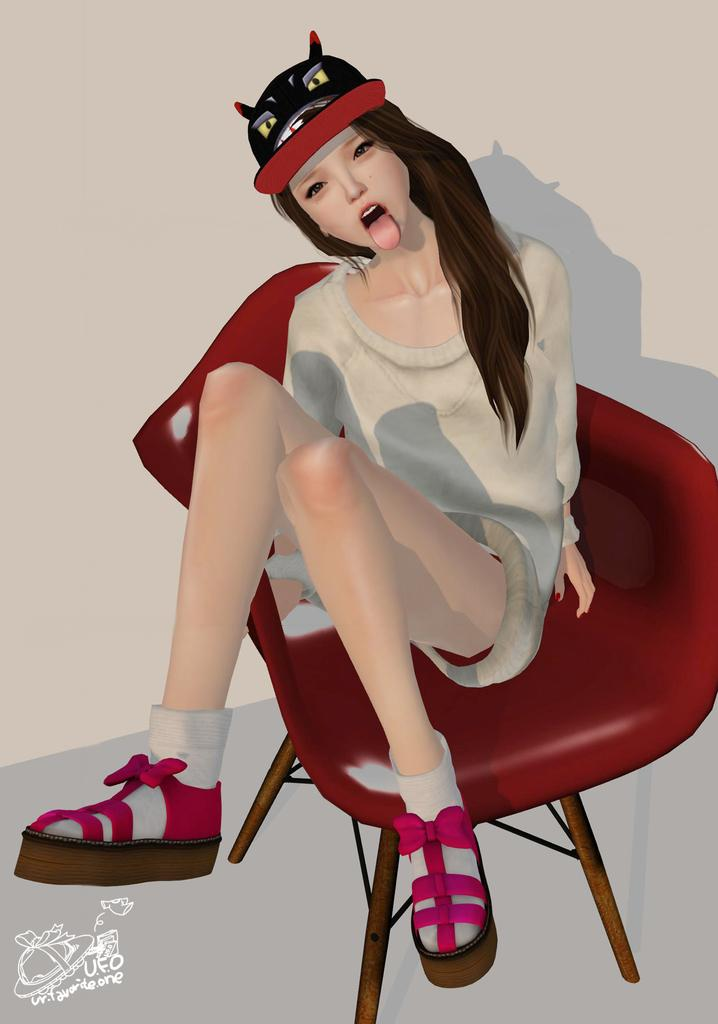What type of image is being described? The image is animated. What color is the chair in the image? There is a red color chair in the image. Who is sitting in the chair? A girl is sitting in the chair. What is the girl wearing on her head? The girl is wearing a cap. What type of skin is visible on the girl's hands in the image? There is no information provided about the girl's hands or skin in the image. What shape is the chair in the image? The shape of the chair is not specified in the image, only the color (red) is mentioned. 